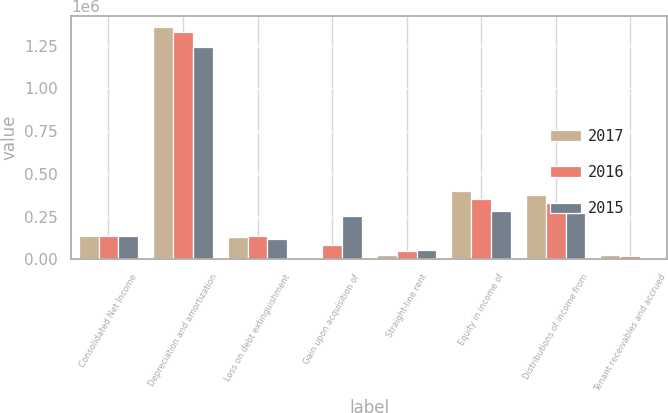Convert chart to OTSL. <chart><loc_0><loc_0><loc_500><loc_500><stacked_bar_chart><ecel><fcel>Consolidated Net Income<fcel>Depreciation and amortization<fcel>Loss on debt extinguishment<fcel>Gain upon acquisition of<fcel>Straight-line rent<fcel>Equity in income of<fcel>Distributions of income from<fcel>Tenant receivables and accrued<nl><fcel>2017<fcel>136777<fcel>1.35735e+06<fcel>128618<fcel>3647<fcel>26543<fcel>400270<fcel>374101<fcel>26170<nl><fcel>2016<fcel>136777<fcel>1.32795e+06<fcel>136777<fcel>84553<fcel>46656<fcel>353334<fcel>331627<fcel>16277<nl><fcel>2015<fcel>136777<fcel>1.23921e+06<fcel>120953<fcel>250516<fcel>54129<fcel>284806<fcel>271998<fcel>9918<nl></chart> 